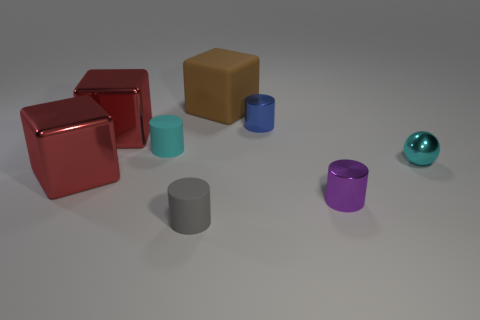What shape is the object behind the blue metallic object? The object positioned behind the blue metallic object is a cube. It has six equal square faces, edges of equal length, and each of its corners forms a right angle. 